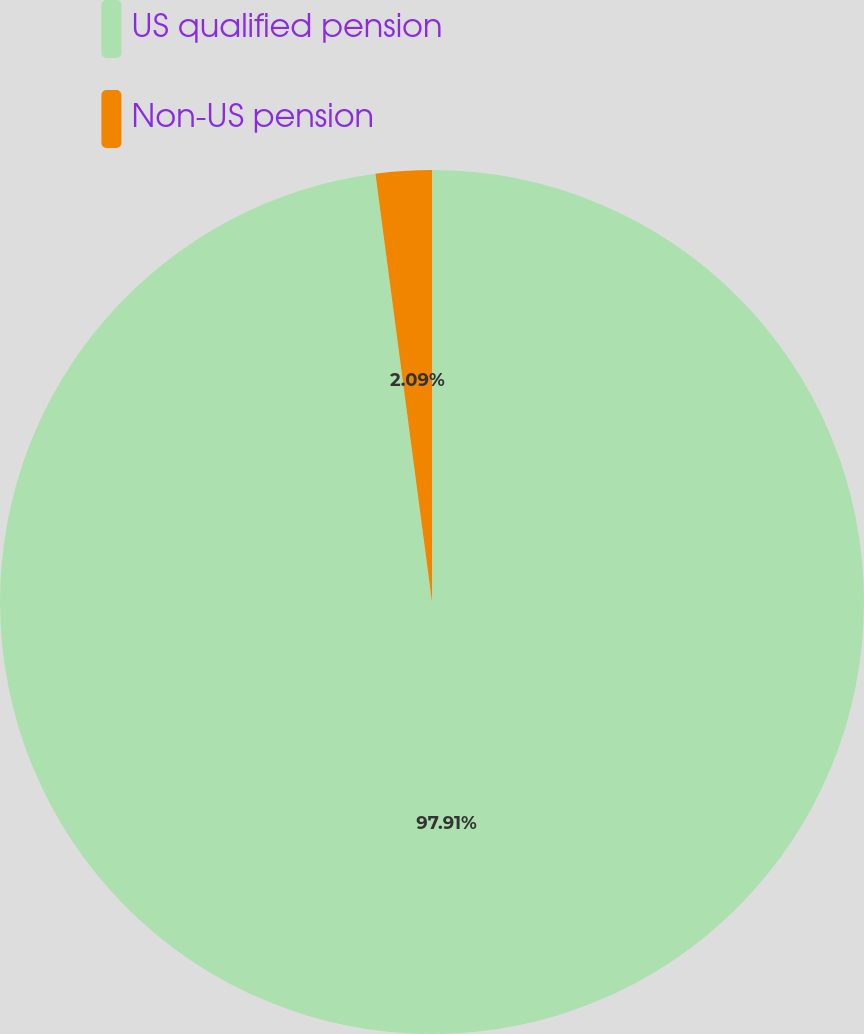Convert chart to OTSL. <chart><loc_0><loc_0><loc_500><loc_500><pie_chart><fcel>US qualified pension<fcel>Non-US pension<nl><fcel>97.91%<fcel>2.09%<nl></chart> 